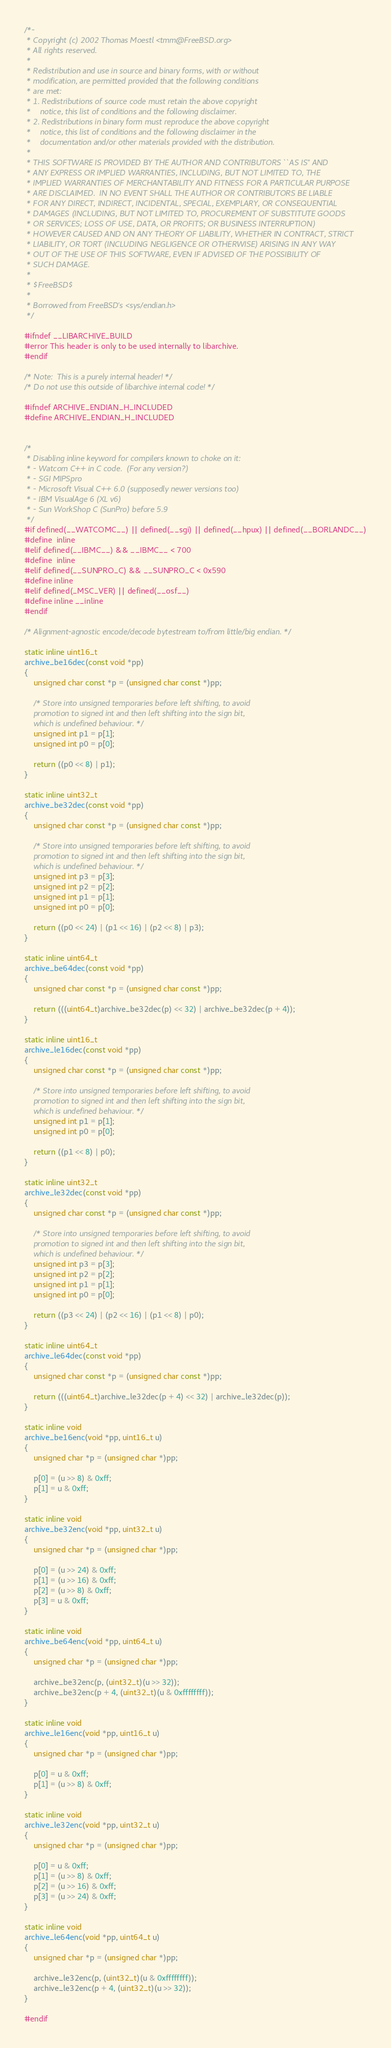<code> <loc_0><loc_0><loc_500><loc_500><_C_>/*-
 * Copyright (c) 2002 Thomas Moestl <tmm@FreeBSD.org>
 * All rights reserved.
 *
 * Redistribution and use in source and binary forms, with or without
 * modification, are permitted provided that the following conditions
 * are met:
 * 1. Redistributions of source code must retain the above copyright
 *    notice, this list of conditions and the following disclaimer.
 * 2. Redistributions in binary form must reproduce the above copyright
 *    notice, this list of conditions and the following disclaimer in the
 *    documentation and/or other materials provided with the distribution.
 *
 * THIS SOFTWARE IS PROVIDED BY THE AUTHOR AND CONTRIBUTORS ``AS IS'' AND
 * ANY EXPRESS OR IMPLIED WARRANTIES, INCLUDING, BUT NOT LIMITED TO, THE
 * IMPLIED WARRANTIES OF MERCHANTABILITY AND FITNESS FOR A PARTICULAR PURPOSE
 * ARE DISCLAIMED.  IN NO EVENT SHALL THE AUTHOR OR CONTRIBUTORS BE LIABLE
 * FOR ANY DIRECT, INDIRECT, INCIDENTAL, SPECIAL, EXEMPLARY, OR CONSEQUENTIAL
 * DAMAGES (INCLUDING, BUT NOT LIMITED TO, PROCUREMENT OF SUBSTITUTE GOODS
 * OR SERVICES; LOSS OF USE, DATA, OR PROFITS; OR BUSINESS INTERRUPTION)
 * HOWEVER CAUSED AND ON ANY THEORY OF LIABILITY, WHETHER IN CONTRACT, STRICT
 * LIABILITY, OR TORT (INCLUDING NEGLIGENCE OR OTHERWISE) ARISING IN ANY WAY
 * OUT OF THE USE OF THIS SOFTWARE, EVEN IF ADVISED OF THE POSSIBILITY OF
 * SUCH DAMAGE.
 *
 * $FreeBSD$
 *
 * Borrowed from FreeBSD's <sys/endian.h>
 */

#ifndef __LIBARCHIVE_BUILD
#error This header is only to be used internally to libarchive.
#endif

/* Note:  This is a purely internal header! */
/* Do not use this outside of libarchive internal code! */

#ifndef ARCHIVE_ENDIAN_H_INCLUDED
#define ARCHIVE_ENDIAN_H_INCLUDED


/*
 * Disabling inline keyword for compilers known to choke on it:
 * - Watcom C++ in C code.  (For any version?)
 * - SGI MIPSpro
 * - Microsoft Visual C++ 6.0 (supposedly newer versions too)
 * - IBM VisualAge 6 (XL v6)
 * - Sun WorkShop C (SunPro) before 5.9
 */
#if defined(__WATCOMC__) || defined(__sgi) || defined(__hpux) || defined(__BORLANDC__)
#define	inline
#elif defined(__IBMC__) && __IBMC__ < 700
#define	inline
#elif defined(__SUNPRO_C) && __SUNPRO_C < 0x590
#define inline
#elif defined(_MSC_VER) || defined(__osf__)
#define inline __inline
#endif

/* Alignment-agnostic encode/decode bytestream to/from little/big endian. */

static inline uint16_t
archive_be16dec(const void *pp)
{
	unsigned char const *p = (unsigned char const *)pp;

	/* Store into unsigned temporaries before left shifting, to avoid
	promotion to signed int and then left shifting into the sign bit,
	which is undefined behaviour. */
	unsigned int p1 = p[1];
	unsigned int p0 = p[0];

	return ((p0 << 8) | p1);
}

static inline uint32_t
archive_be32dec(const void *pp)
{
	unsigned char const *p = (unsigned char const *)pp;

	/* Store into unsigned temporaries before left shifting, to avoid
	promotion to signed int and then left shifting into the sign bit,
	which is undefined behaviour. */
	unsigned int p3 = p[3];
	unsigned int p2 = p[2];
	unsigned int p1 = p[1];
	unsigned int p0 = p[0];

	return ((p0 << 24) | (p1 << 16) | (p2 << 8) | p3);
}

static inline uint64_t
archive_be64dec(const void *pp)
{
	unsigned char const *p = (unsigned char const *)pp;

	return (((uint64_t)archive_be32dec(p) << 32) | archive_be32dec(p + 4));
}

static inline uint16_t
archive_le16dec(const void *pp)
{
	unsigned char const *p = (unsigned char const *)pp;

	/* Store into unsigned temporaries before left shifting, to avoid
	promotion to signed int and then left shifting into the sign bit,
	which is undefined behaviour. */
	unsigned int p1 = p[1];
	unsigned int p0 = p[0];

	return ((p1 << 8) | p0);
}

static inline uint32_t
archive_le32dec(const void *pp)
{
	unsigned char const *p = (unsigned char const *)pp;

	/* Store into unsigned temporaries before left shifting, to avoid
	promotion to signed int and then left shifting into the sign bit,
	which is undefined behaviour. */
	unsigned int p3 = p[3];
	unsigned int p2 = p[2];
	unsigned int p1 = p[1];
	unsigned int p0 = p[0];

	return ((p3 << 24) | (p2 << 16) | (p1 << 8) | p0);
}

static inline uint64_t
archive_le64dec(const void *pp)
{
	unsigned char const *p = (unsigned char const *)pp;

	return (((uint64_t)archive_le32dec(p + 4) << 32) | archive_le32dec(p));
}

static inline void
archive_be16enc(void *pp, uint16_t u)
{
	unsigned char *p = (unsigned char *)pp;

	p[0] = (u >> 8) & 0xff;
	p[1] = u & 0xff;
}

static inline void
archive_be32enc(void *pp, uint32_t u)
{
	unsigned char *p = (unsigned char *)pp;

	p[0] = (u >> 24) & 0xff;
	p[1] = (u >> 16) & 0xff;
	p[2] = (u >> 8) & 0xff;
	p[3] = u & 0xff;
}

static inline void
archive_be64enc(void *pp, uint64_t u)
{
	unsigned char *p = (unsigned char *)pp;

	archive_be32enc(p, (uint32_t)(u >> 32));
	archive_be32enc(p + 4, (uint32_t)(u & 0xffffffff));
}

static inline void
archive_le16enc(void *pp, uint16_t u)
{
	unsigned char *p = (unsigned char *)pp;

	p[0] = u & 0xff;
	p[1] = (u >> 8) & 0xff;
}

static inline void
archive_le32enc(void *pp, uint32_t u)
{
	unsigned char *p = (unsigned char *)pp;

	p[0] = u & 0xff;
	p[1] = (u >> 8) & 0xff;
	p[2] = (u >> 16) & 0xff;
	p[3] = (u >> 24) & 0xff;
}

static inline void
archive_le64enc(void *pp, uint64_t u)
{
	unsigned char *p = (unsigned char *)pp;

	archive_le32enc(p, (uint32_t)(u & 0xffffffff));
	archive_le32enc(p + 4, (uint32_t)(u >> 32));
}

#endif
</code> 